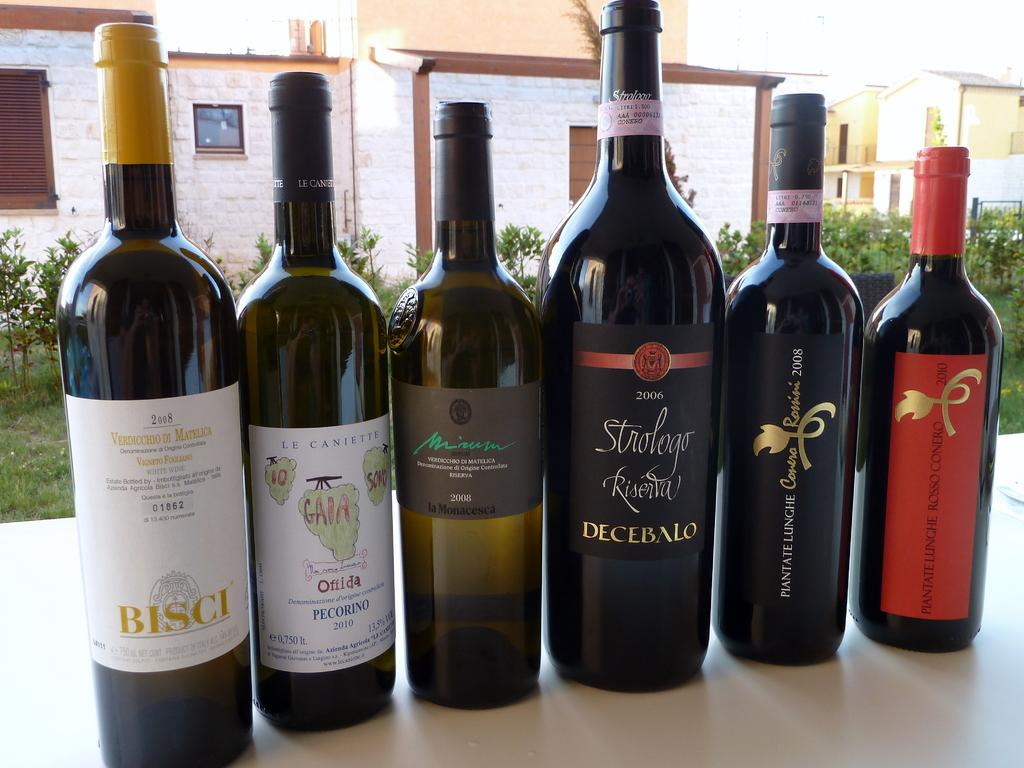<image>
Summarize the visual content of the image. Bottles of alcohol in a row with one that says "BISCI" on it. 